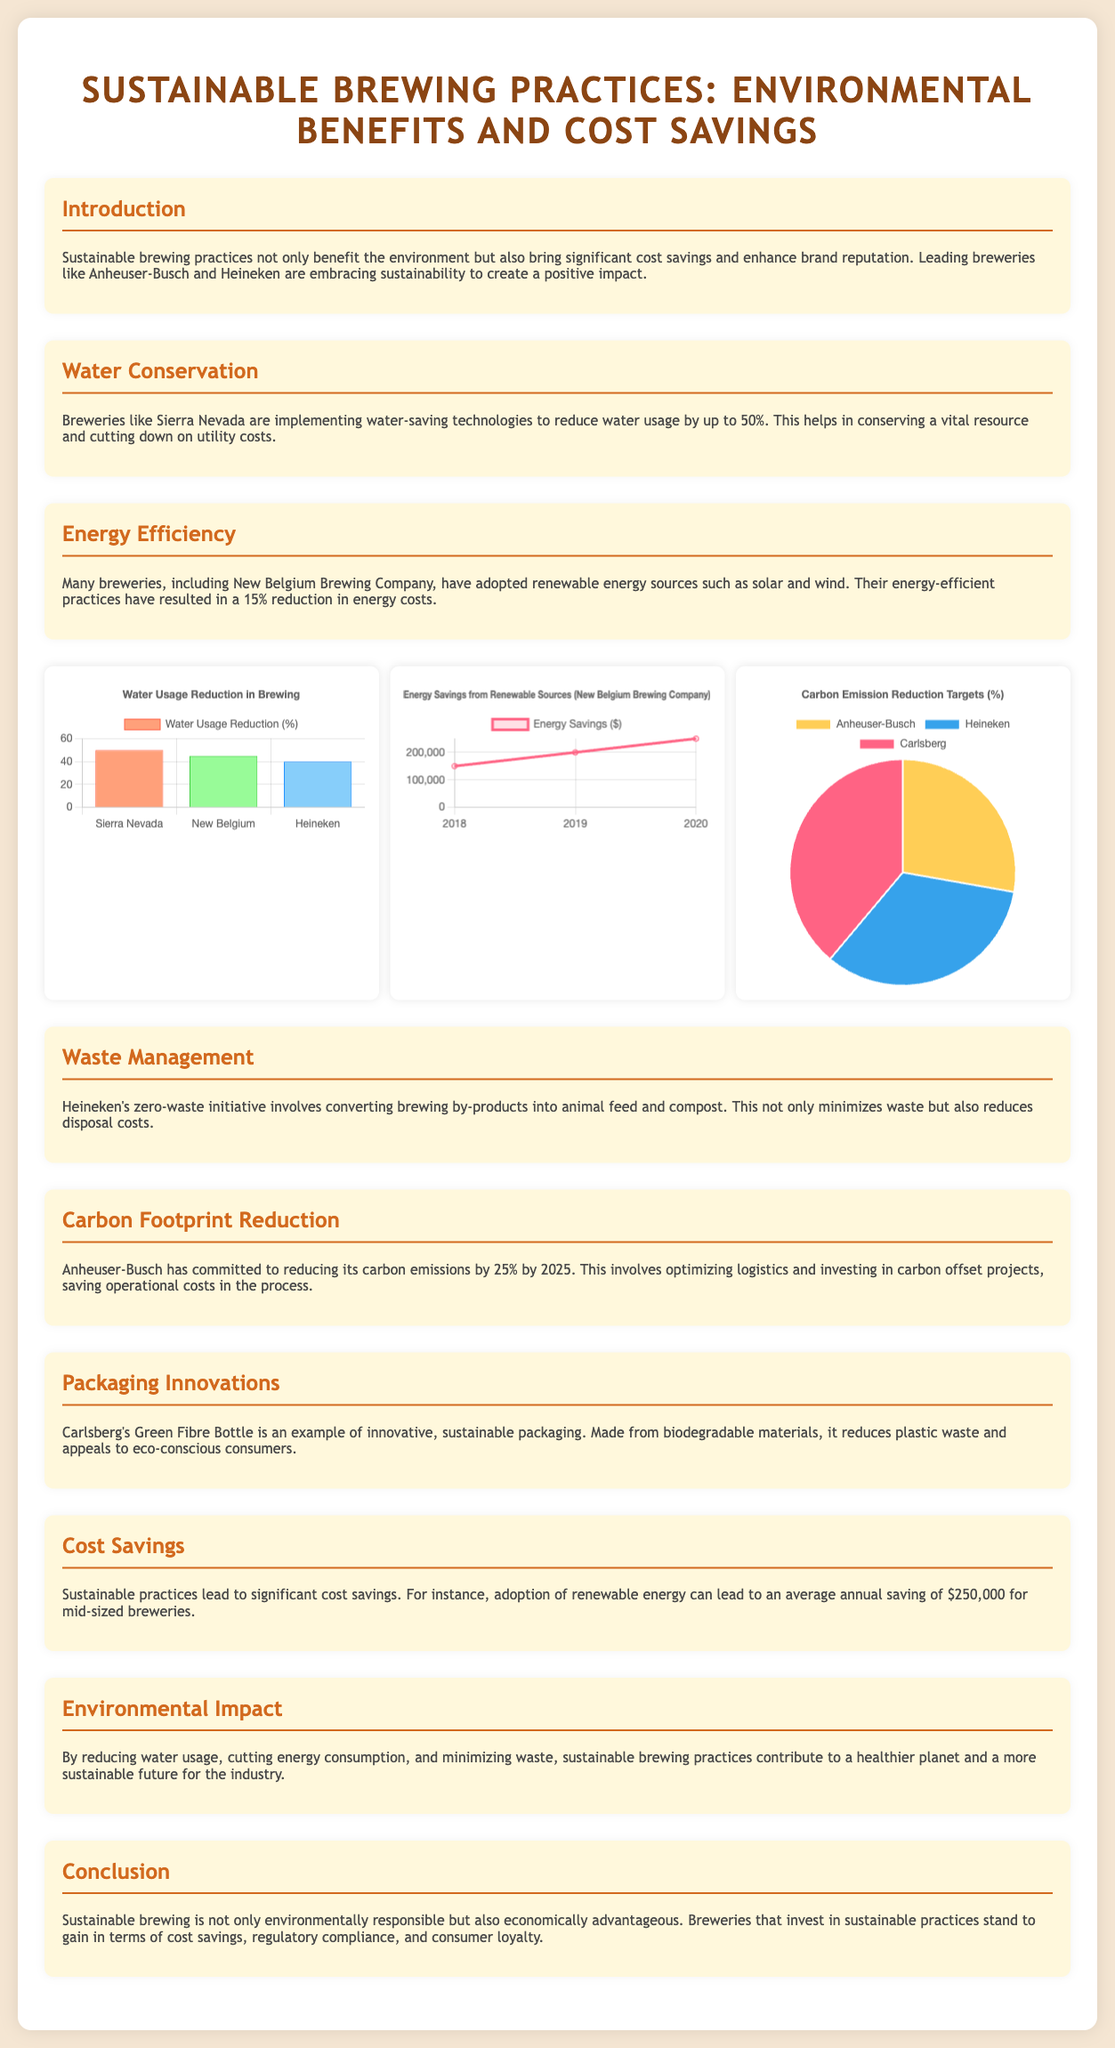What reduction in water usage was achieved by Sierra Nevada? Sierra Nevada implemented water-saving technologies resulting in a reduction of water usage by 50%.
Answer: 50% What year did New Belgium Brewing Company start to show energy savings? The energy savings data for New Belgium Brewing Company is presented starting from 2018.
Answer: 2018 What is the target percentage for carbon emission reduction set by Anheuser-Busch? Anheuser-Busch has committed to a carbon emissions reduction target of 25% by 2025.
Answer: 25% What is the average annual saving for mid-sized breweries adopting renewable energy? The document states that mid-sized breweries can save an average of $250,000 annually by adopting renewable energy.
Answer: $250,000 Which brewery has a zero-waste initiative? Heineken's zero-waste initiative is highlighted in the document for converting brewing by-products into animal feed and compost.
Answer: Heineken What type of packaging innovation is mentioned in the document? The Green Fibre Bottle made by Carlsberg is mentioned as an example of innovative sustainable packaging.
Answer: Green Fibre Bottle What year shows the highest energy savings reported? The highest energy savings reported is in the year 2020, with savings of $250,000.
Answer: 2020 What percentage of carbon emission reduction targets has Carlsberg set? The document states Carlsberg aims for carbon emission reduction of 35%.
Answer: 35% What is the main environmental benefit of sustainable brewing practices outlined? The main environmental benefit is reducing water usage, cutting energy consumption, and minimizing waste.
Answer: Environmental benefit 